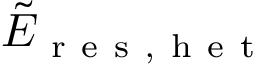Convert formula to latex. <formula><loc_0><loc_0><loc_500><loc_500>\tilde { E } _ { r e s , h e t }</formula> 